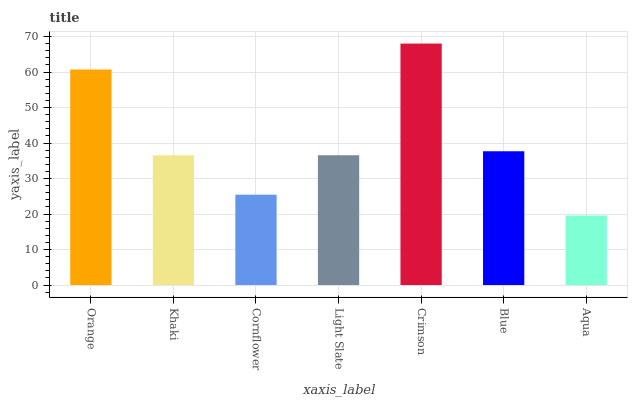Is Aqua the minimum?
Answer yes or no. Yes. Is Crimson the maximum?
Answer yes or no. Yes. Is Khaki the minimum?
Answer yes or no. No. Is Khaki the maximum?
Answer yes or no. No. Is Orange greater than Khaki?
Answer yes or no. Yes. Is Khaki less than Orange?
Answer yes or no. Yes. Is Khaki greater than Orange?
Answer yes or no. No. Is Orange less than Khaki?
Answer yes or no. No. Is Light Slate the high median?
Answer yes or no. Yes. Is Light Slate the low median?
Answer yes or no. Yes. Is Crimson the high median?
Answer yes or no. No. Is Khaki the low median?
Answer yes or no. No. 